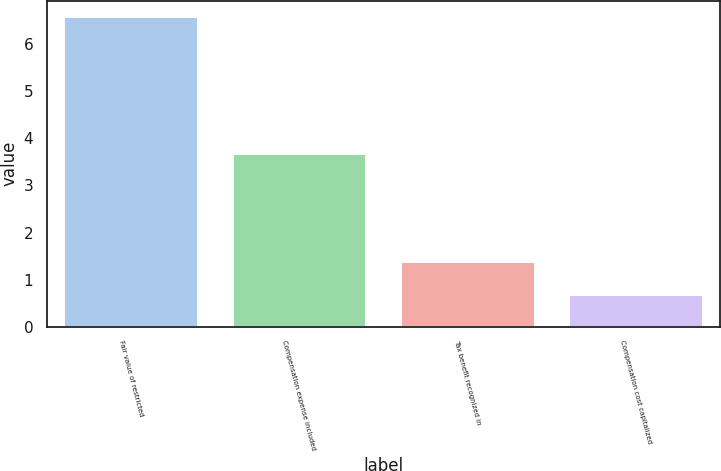Convert chart to OTSL. <chart><loc_0><loc_0><loc_500><loc_500><bar_chart><fcel>Fair value of restricted<fcel>Compensation expense included<fcel>Tax benefit recognized in<fcel>Compensation cost capitalized<nl><fcel>6.6<fcel>3.7<fcel>1.4<fcel>0.7<nl></chart> 